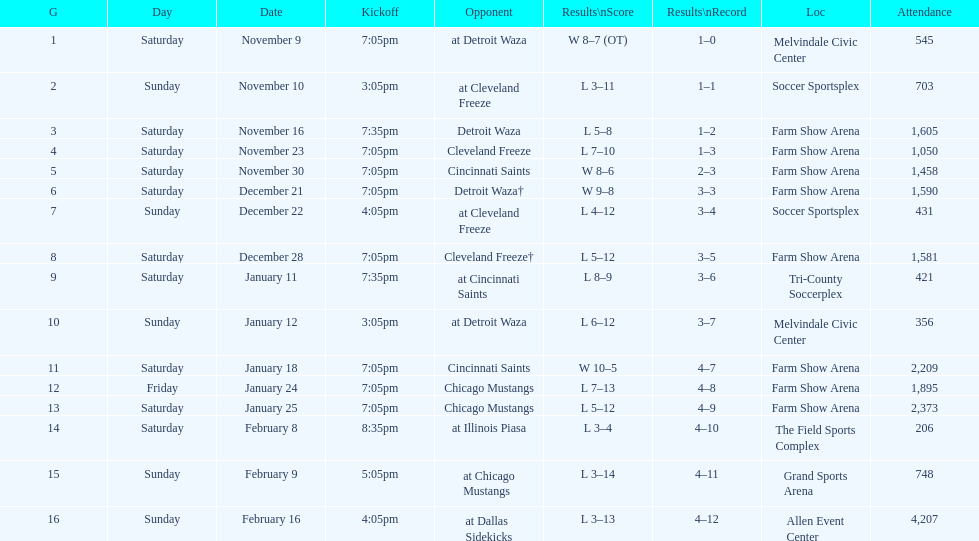Which opponent is listed after cleveland freeze in the table? Detroit Waza. 